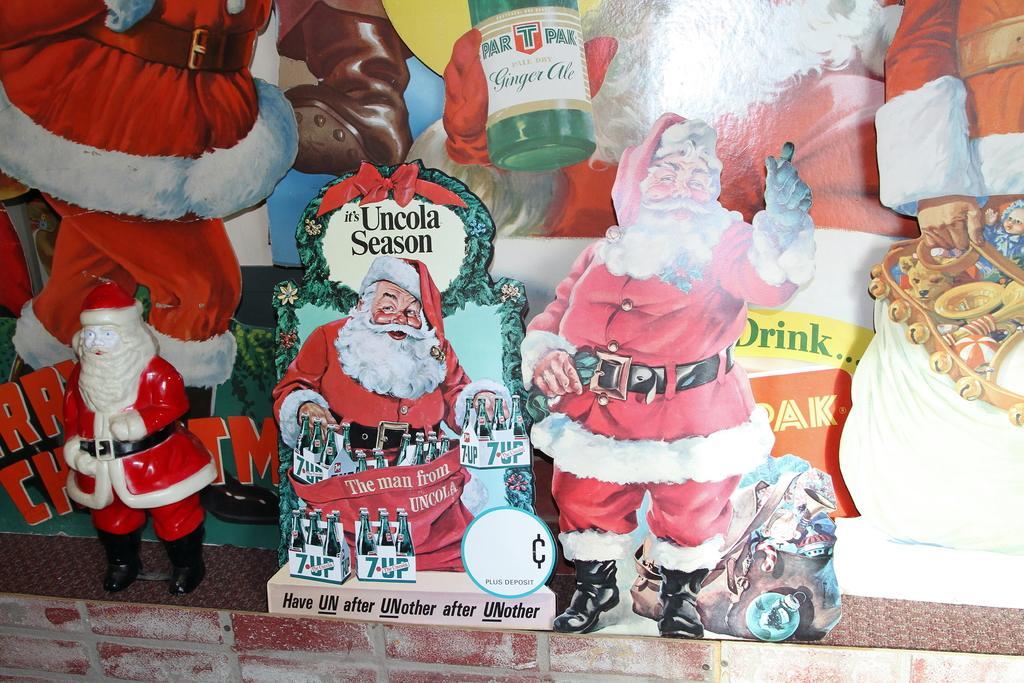Describe this image in one or two sentences. Here we can see hoardings of a Santa Claus and a toy on a platform. 